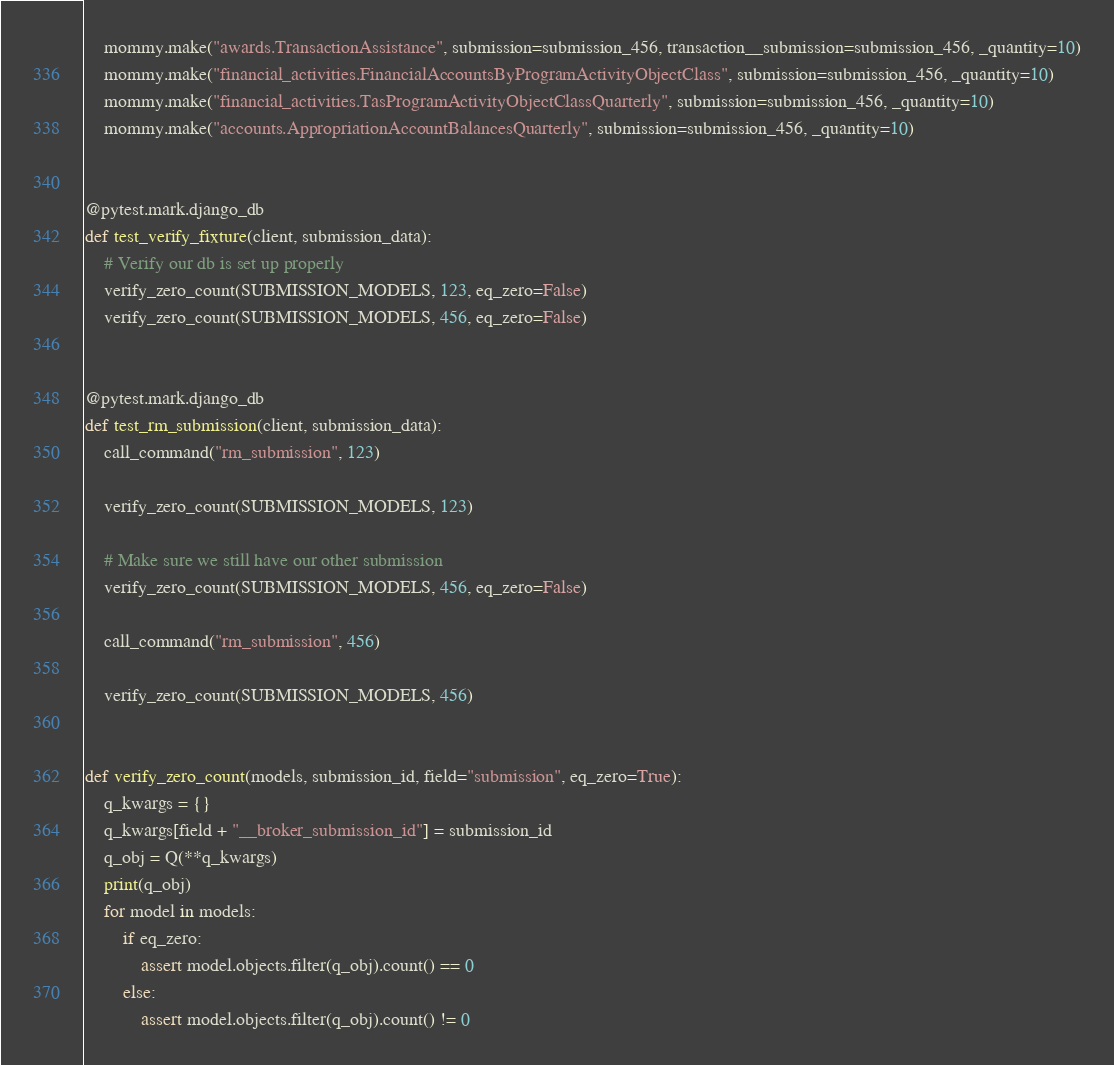Convert code to text. <code><loc_0><loc_0><loc_500><loc_500><_Python_>    mommy.make("awards.TransactionAssistance", submission=submission_456, transaction__submission=submission_456, _quantity=10)
    mommy.make("financial_activities.FinancialAccountsByProgramActivityObjectClass", submission=submission_456, _quantity=10)
    mommy.make("financial_activities.TasProgramActivityObjectClassQuarterly", submission=submission_456, _quantity=10)
    mommy.make("accounts.AppropriationAccountBalancesQuarterly", submission=submission_456, _quantity=10)


@pytest.mark.django_db
def test_verify_fixture(client, submission_data):
    # Verify our db is set up properly
    verify_zero_count(SUBMISSION_MODELS, 123, eq_zero=False)
    verify_zero_count(SUBMISSION_MODELS, 456, eq_zero=False)


@pytest.mark.django_db
def test_rm_submission(client, submission_data):
    call_command("rm_submission", 123)

    verify_zero_count(SUBMISSION_MODELS, 123)

    # Make sure we still have our other submission
    verify_zero_count(SUBMISSION_MODELS, 456, eq_zero=False)

    call_command("rm_submission", 456)

    verify_zero_count(SUBMISSION_MODELS, 456)


def verify_zero_count(models, submission_id, field="submission", eq_zero=True):
    q_kwargs = {}
    q_kwargs[field + "__broker_submission_id"] = submission_id
    q_obj = Q(**q_kwargs)
    print(q_obj)
    for model in models:
        if eq_zero:
            assert model.objects.filter(q_obj).count() == 0
        else:
            assert model.objects.filter(q_obj).count() != 0
</code> 